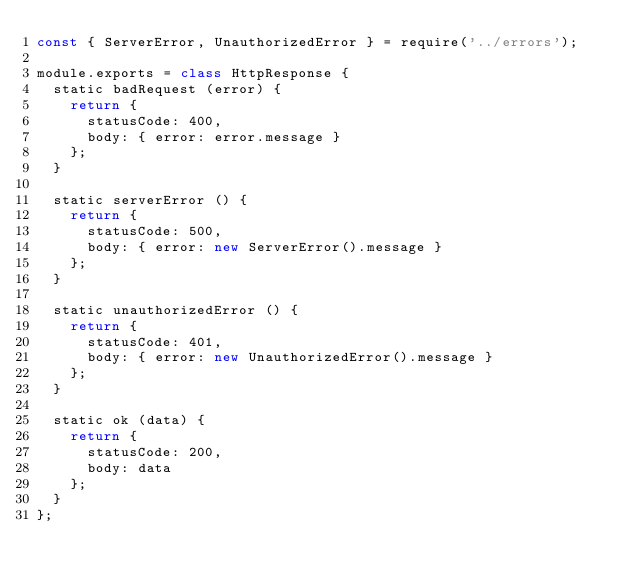Convert code to text. <code><loc_0><loc_0><loc_500><loc_500><_JavaScript_>const { ServerError, UnauthorizedError } = require('../errors');

module.exports = class HttpResponse {
  static badRequest (error) {
    return {
      statusCode: 400,
      body: { error: error.message }
    };
  }

  static serverError () {
    return {
      statusCode: 500,
      body: { error: new ServerError().message }
    };
  }

  static unauthorizedError () {
    return {
      statusCode: 401,
      body: { error: new UnauthorizedError().message }
    };
  }

  static ok (data) {
    return {
      statusCode: 200,
      body: data
    };
  }
};
</code> 